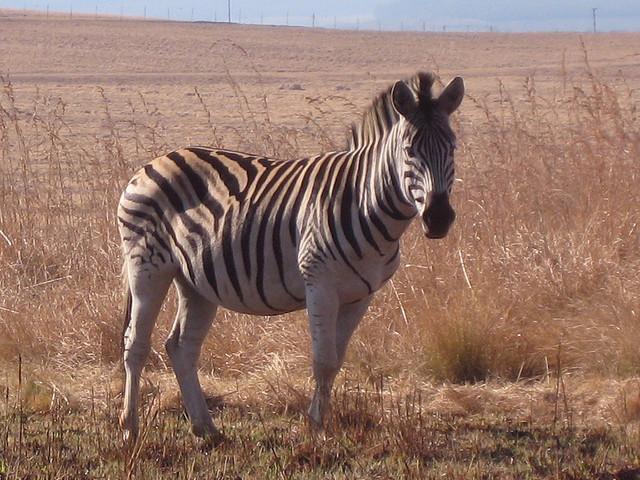How many vases glass vases are on the table?
Give a very brief answer. 0. 